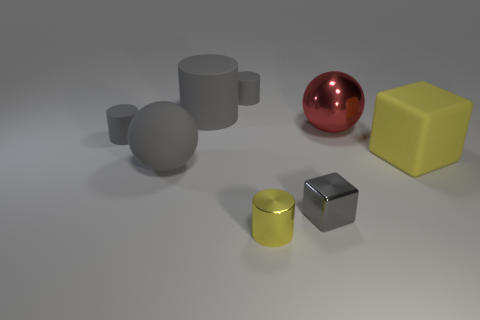There is a matte cylinder that is left of the rubber sphere; is its size the same as the large yellow rubber object?
Your answer should be very brief. No. What number of things are either tiny things in front of the big metal ball or small blue rubber things?
Provide a succinct answer. 3. Are there any yellow rubber things that have the same size as the gray rubber sphere?
Your response must be concise. Yes. There is a block that is the same size as the yellow cylinder; what material is it?
Your response must be concise. Metal. What is the shape of the large thing that is to the right of the tiny block and behind the large yellow rubber cube?
Give a very brief answer. Sphere. There is a large sphere that is in front of the big yellow block; what is its color?
Provide a succinct answer. Gray. How big is the gray object that is both in front of the yellow rubber thing and behind the tiny block?
Your answer should be compact. Large. Does the yellow cube have the same material as the small gray thing to the left of the big gray cylinder?
Offer a terse response. Yes. How many yellow shiny things are the same shape as the gray metal object?
Offer a very short reply. 0. What material is the cube that is the same color as the large matte sphere?
Your answer should be compact. Metal. 